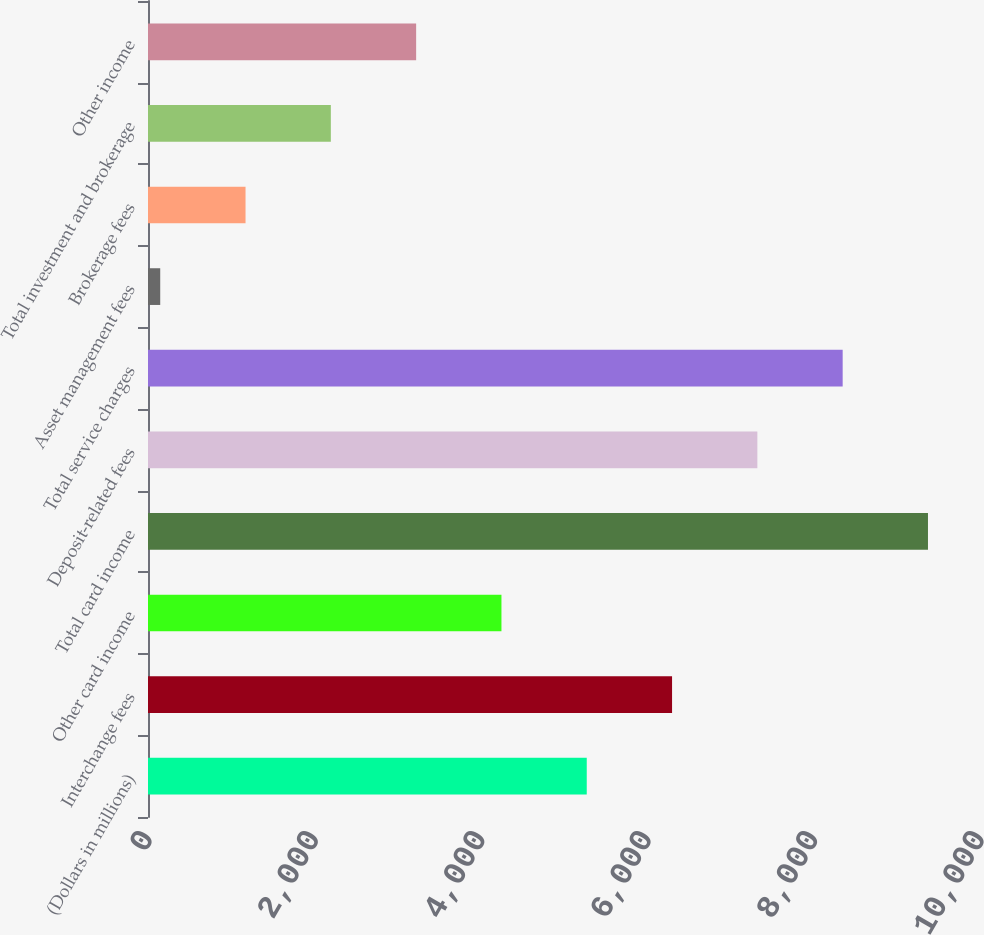Convert chart to OTSL. <chart><loc_0><loc_0><loc_500><loc_500><bar_chart><fcel>(Dollars in millions)<fcel>Interchange fees<fcel>Other card income<fcel>Total card income<fcel>Deposit-related fees<fcel>Total service charges<fcel>Asset management fees<fcel>Brokerage fees<fcel>Total investment and brokerage<fcel>Other income<nl><fcel>5273.5<fcel>6298.8<fcel>4248.2<fcel>9374.7<fcel>7324.1<fcel>8349.4<fcel>147<fcel>1172.3<fcel>2197.6<fcel>3222.9<nl></chart> 